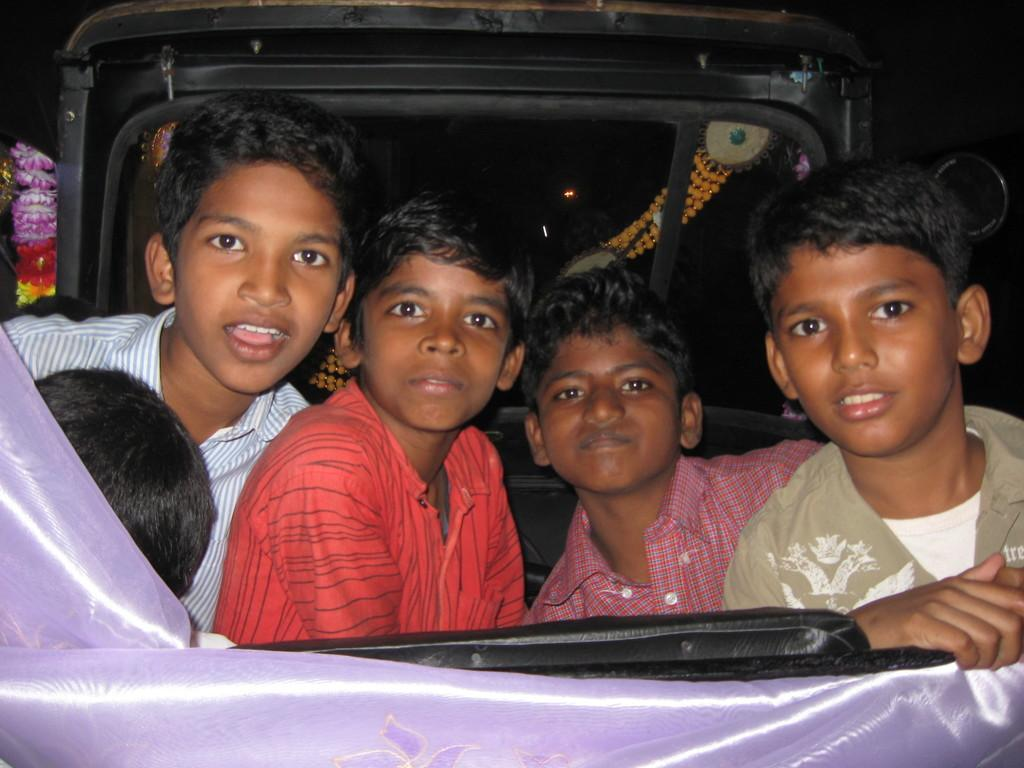How many people are in the image? There are a few people in the image. What else can be seen in the image besides the people? There is a vehicle in the image. What is notable about the vehicle? The vehicle has objects attached to it. What type of material is visible in the image? There is cloth visible in the image. Can you describe the color of one of the objects in the image? There is a black colored object in the image. How many cards can be seen falling from the sky in the image? There are no cards or any falling objects visible in the image. 